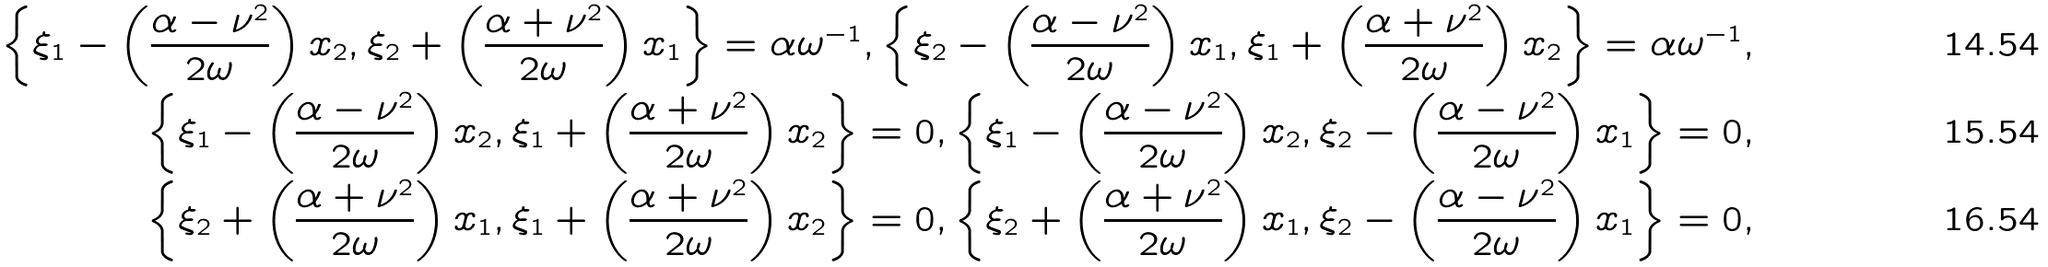<formula> <loc_0><loc_0><loc_500><loc_500>\left \{ \xi _ { 1 } - \left ( \frac { \alpha - \nu ^ { 2 } } { 2 \omega } \right ) x _ { 2 } , \xi _ { 2 } + \left ( \frac { \alpha + \nu ^ { 2 } } { 2 \omega } \right ) x _ { 1 } \right \} = \alpha \omega ^ { - 1 } , \left \{ \xi _ { 2 } - \left ( \frac { \alpha - \nu ^ { 2 } } { 2 \omega } \right ) x _ { 1 } , \xi _ { 1 } + \left ( \frac { \alpha + \nu ^ { 2 } } { 2 \omega } \right ) x _ { 2 } \right \} = \alpha \omega ^ { - 1 } , \\ \left \{ \xi _ { 1 } - \left ( \frac { \alpha - \nu ^ { 2 } } { 2 \omega } \right ) x _ { 2 } , \xi _ { 1 } + \left ( \frac { \alpha + \nu ^ { 2 } } { 2 \omega } \right ) x _ { 2 } \right \} = 0 , \left \{ \xi _ { 1 } - \left ( \frac { \alpha - \nu ^ { 2 } } { 2 \omega } \right ) x _ { 2 } , \xi _ { 2 } - \left ( \frac { \alpha - \nu ^ { 2 } } { 2 \omega } \right ) x _ { 1 } \right \} = 0 , \\ \left \{ \xi _ { 2 } + \left ( \frac { \alpha + \nu ^ { 2 } } { 2 \omega } \right ) x _ { 1 } , \xi _ { 1 } + \left ( \frac { \alpha + \nu ^ { 2 } } { 2 \omega } \right ) x _ { 2 } \right \} = 0 , \left \{ \xi _ { 2 } + \left ( \frac { \alpha + \nu ^ { 2 } } { 2 \omega } \right ) x _ { 1 } , \xi _ { 2 } - \left ( \frac { \alpha - \nu ^ { 2 } } { 2 \omega } \right ) x _ { 1 } \right \} = 0 ,</formula> 